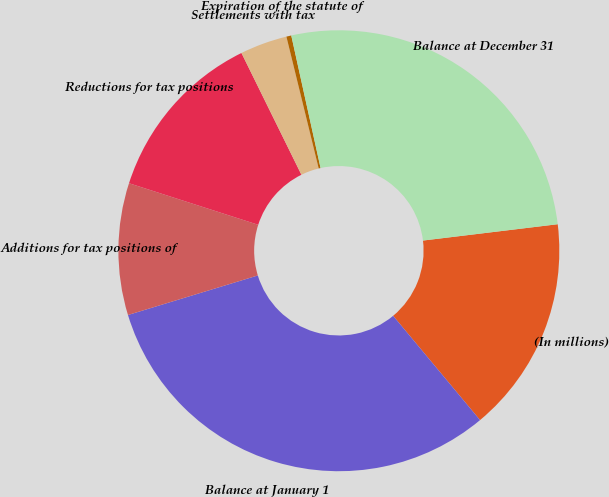<chart> <loc_0><loc_0><loc_500><loc_500><pie_chart><fcel>(In millions)<fcel>Balance at January 1<fcel>Additions for tax positions of<fcel>Reductions for tax positions<fcel>Settlements with tax<fcel>Expiration of the statute of<fcel>Balance at December 31<nl><fcel>15.86%<fcel>31.35%<fcel>9.66%<fcel>12.76%<fcel>3.46%<fcel>0.36%<fcel>26.54%<nl></chart> 